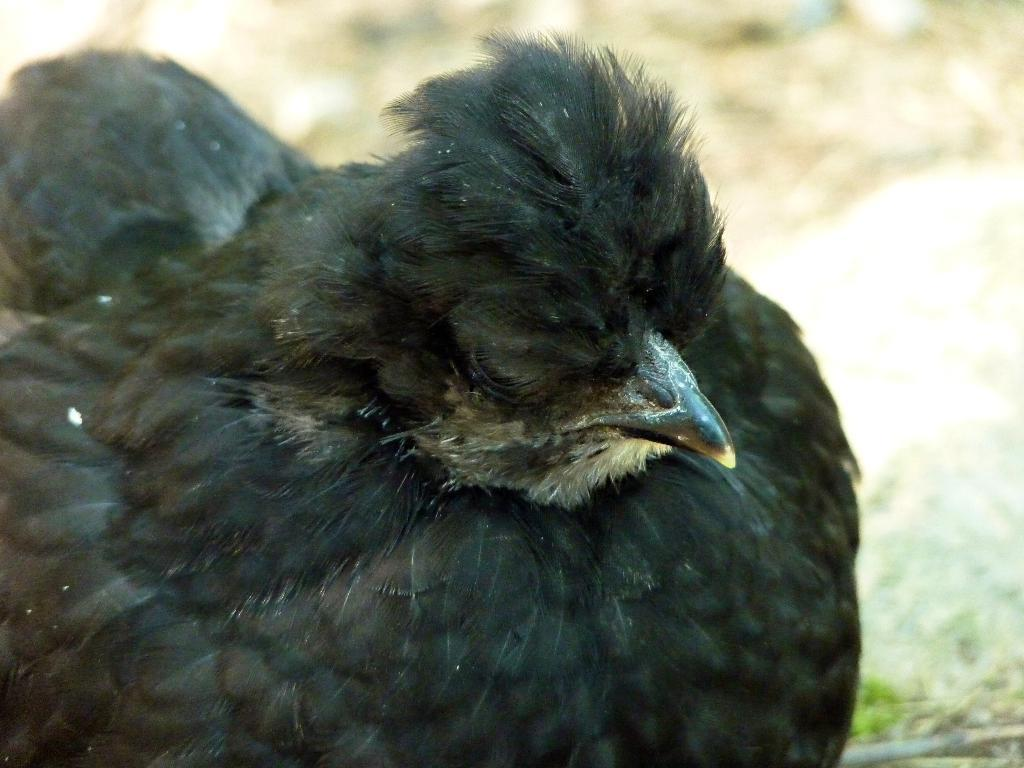What type of animal is in the image? There is a bird in the image. What color is the bird? The bird is black in color. Can you describe the background of the image? The background of the image is blurry. What type of pear is hanging from the arch in the image? There is no pear or arch present in the image; it features a black bird with a blurry background. 